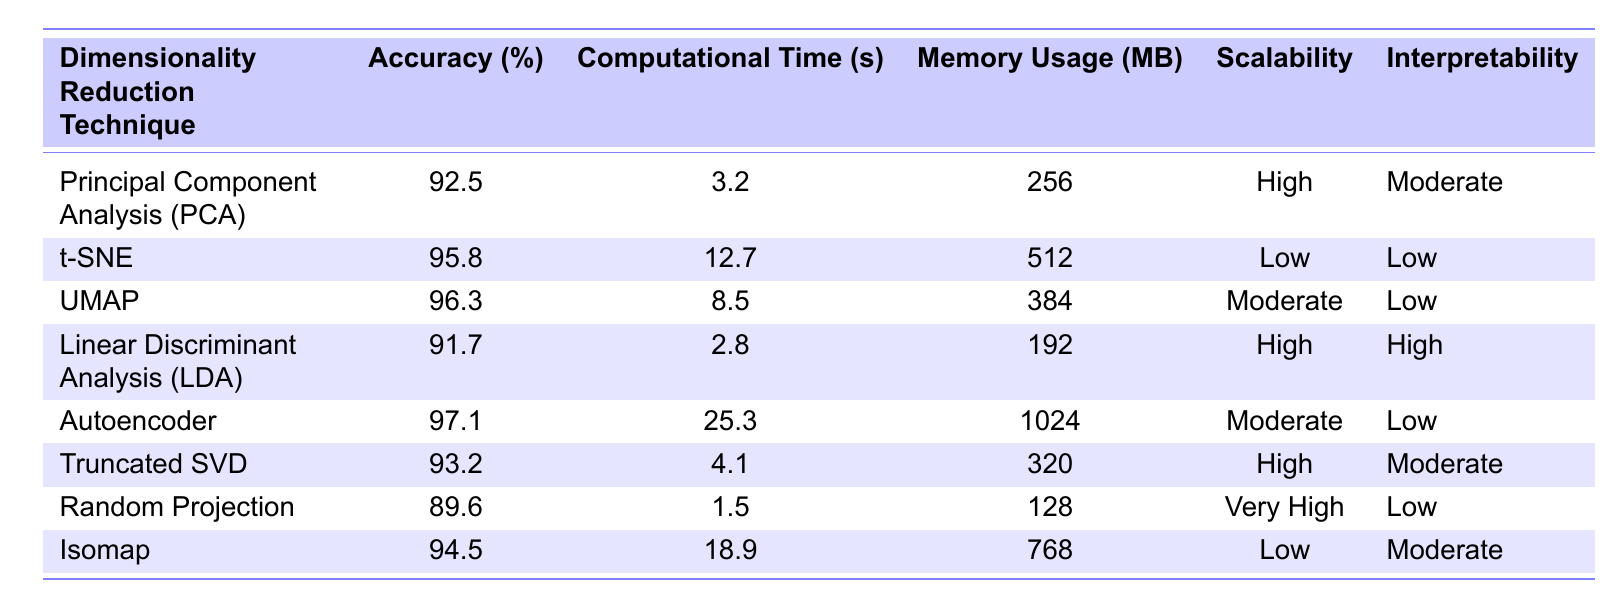What is the accuracy of UMAP? The table shows that UMAP has an accuracy of 96.3%.
Answer: 96.3% Which technique has the lowest computational time? By examining the table, Random Projection has the lowest computational time of 1.5 seconds.
Answer: 1.5 seconds What is the memory usage of the Autoencoder? The table indicates that the Autoencoder uses 1024 MB of memory.
Answer: 1024 MB Is the scalability of t-SNE high? The table shows that t-SNE has low scalability. Therefore, the statement is false.
Answer: No What is the difference in accuracy between Autoencoder and LDA? The accuracy of Autoencoder is 97.1% and LDA is 91.7%. The difference is 97.1 - 91.7 = 5.4%.
Answer: 5.4% Which technique provides the highest accuracy and what is its computational time? The highest accuracy is from Autoencoder at 97.1%, which has a computational time of 25.3 seconds.
Answer: Autoencoder, 25.3 seconds What is the average memory usage of the techniques listed? The memory usages are 256, 512, 384, 192, 1024, 320, 128, and 768 MB. Adding these gives 256 + 512 + 384 + 192 + 1024 + 320 + 128 + 768 = 3084 MB. Dividing by 8 techniques provides an average of 3084/8 = 385.5 MB.
Answer: 385.5 MB Which technique has the best accuracy-to-time ratio? To find the best accuracy-to-time ratio, calculate accuracy/time for each technique: PCA (28.84), t-SNE (7.55), UMAP (11.32), LDA (32.68), Autoencoder (3.84), Truncated SVD (22.68), Random Projection (59.73), Isomap (4.91). Random Projection has the highest ratio of 59.73.
Answer: Random Projection Which dimensionality reduction technique is both highly scalable and interpretable? The table shows that both scalability and interpretability are high for Linear Discriminant Analysis (LDA).
Answer: Linear Discriminant Analysis (LDA) 